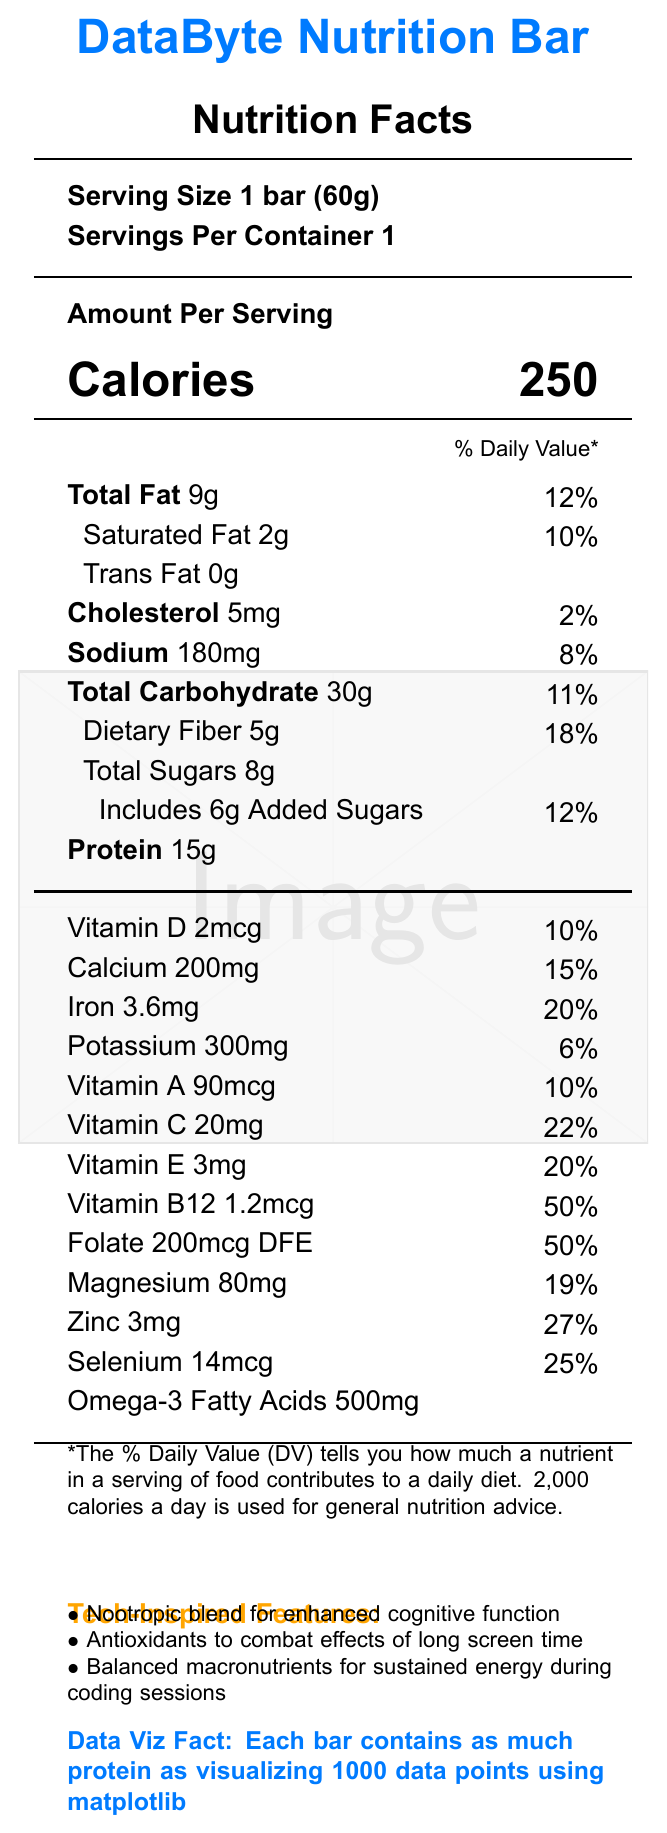What is the serving size for the DataByte Nutrition Bar? The document states the serving size as 1 bar, which weighs 60 grams.
Answer: 1 bar (60g) How many calories are in one DataByte Nutrition Bar? The document lists the calorie content as 250 calories per bar.
Answer: 250 calories What percentage of the daily value for iron does one DataByte Nutrition Bar provide? The document states that one bar provides 3.6mg of iron, which is 20% of the daily value.
Answer: 20% List three tech-inspired features of the DataByte Nutrition Bar. These features are highlighted under the "Tech-Inspired Features" section of the document.
Answer: Nootropic blend for enhanced cognitive function, Antioxidants to combat effects of long screen time, Balanced macronutrients for sustained energy during coding sessions How much protein does each DataByte Nutrition Bar contain? The document specifies that each bar contains 15 grams of protein.
Answer: 15g What is the amount of added sugars in the DataByte Nutrition Bar? The document shows the amount of added sugars as 6 grams.
Answer: 6g Which vitamin has the highest daily value percentage in one serving of the DataByte Nutrition Bar?
A. Vitamin D
B. Vitamin A
C. Vitamin B12
D. Vitamin C Vitamin B12 has a daily value of 50%, which is the highest among the listed vitamins.
Answer: C. Vitamin B12 What is the total fat content in one DataByte Nutrition Bar? The document states that the total fat content is 9 grams.
Answer: 9g Is the DataByte Nutrition Bar suitable for someone with a nut allergy? The allergen information indicates that the bar contains almonds, so it is not suitable for someone with a nut allergy.
Answer: No Which mineral provides a daily value of 19% in the DataByte Nutrition Bar?
A. Iron
B. Zinc
C. Magnesium
D. Calcium Magnesium provides a daily value of 19%, as stated in the document.
Answer: C. Magnesium Summarize the key nutritional information and features of the DataByte Nutrition Bar. The document provides a comprehensive breakdown of the nutritional content and highlights the bar's technological design elements to enhance cognitive and physical performance for busy data scientists.
Answer: The DataByte Nutrition Bar contains 250 calories per serving, with 9g of total fat, 30g of carbohydrates, and 15g of protein. It is rich in essential vitamins and minerals, including Vitamin B12 (50% DV), Iron (20% DV), Magnesium (19% DV), and Zinc (27% DV). The bar also includes tech-inspired features such as a nootropic blend for cognitive function, antioxidants for long screen time, and balanced macronutrients for sustained energy. What is the percentage of daily value for dietary fiber in one serving of the DataByte Nutrition Bar? The document lists the dietary fiber content as 5g, which corresponds to 18% of the daily value.
Answer: 18% Does the DataByte Nutrition Bar contain any trans fat? The document indicates that the bar contains 0g of trans fat.
Answer: No How much calcium is in one DataByte Nutrition Bar, and what percentage of the daily value does this represent? The document states that each bar contains 200mg of calcium, which is 15% of the daily value.
Answer: 200mg, 15% Does the DataByte Nutrition Bar help in enhancing cognitive function? The tech-inspired features mention a nootropic blend for enhanced cognitive function.
Answer: Yes What is the recommended serving size for a child under 10 years old? The document does not provide information on serving sizes for children or any specific recommendations for different age groups.
Answer: Cannot be determined 